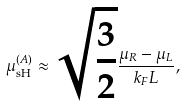Convert formula to latex. <formula><loc_0><loc_0><loc_500><loc_500>\mu _ { \text {sH} } ^ { ( A ) } \approx \sqrt { \frac { 3 } { 2 } } \frac { \mu _ { R } - \mu _ { L } } { k _ { F } L } ,</formula> 